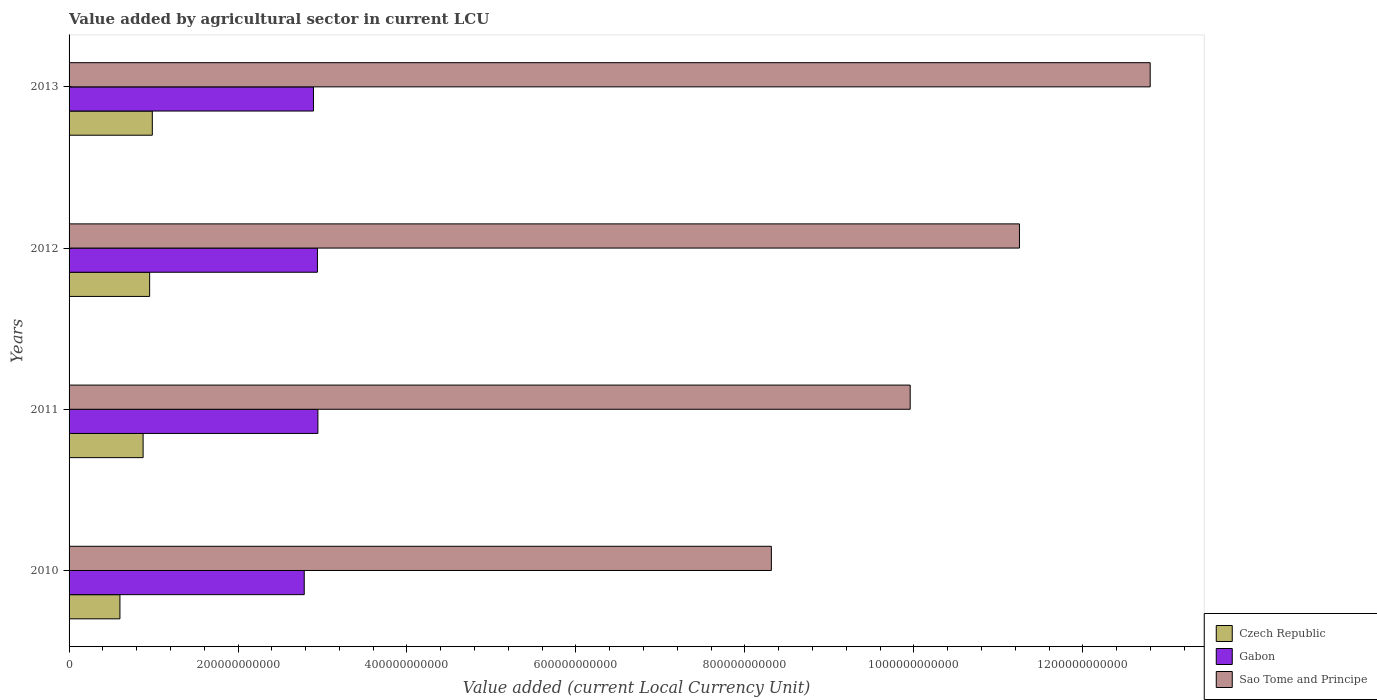How many groups of bars are there?
Offer a very short reply. 4. Are the number of bars per tick equal to the number of legend labels?
Make the answer very short. Yes. Are the number of bars on each tick of the Y-axis equal?
Your response must be concise. Yes. How many bars are there on the 4th tick from the top?
Ensure brevity in your answer.  3. What is the value added by agricultural sector in Czech Republic in 2013?
Offer a terse response. 9.85e+1. Across all years, what is the maximum value added by agricultural sector in Gabon?
Your response must be concise. 2.95e+11. Across all years, what is the minimum value added by agricultural sector in Sao Tome and Principe?
Offer a terse response. 8.31e+11. In which year was the value added by agricultural sector in Sao Tome and Principe minimum?
Give a very brief answer. 2010. What is the total value added by agricultural sector in Sao Tome and Principe in the graph?
Provide a short and direct response. 4.23e+12. What is the difference between the value added by agricultural sector in Czech Republic in 2010 and that in 2011?
Ensure brevity in your answer.  -2.74e+1. What is the difference between the value added by agricultural sector in Czech Republic in 2010 and the value added by agricultural sector in Gabon in 2013?
Make the answer very short. -2.29e+11. What is the average value added by agricultural sector in Sao Tome and Principe per year?
Ensure brevity in your answer.  1.06e+12. In the year 2011, what is the difference between the value added by agricultural sector in Sao Tome and Principe and value added by agricultural sector in Gabon?
Your response must be concise. 7.01e+11. What is the ratio of the value added by agricultural sector in Czech Republic in 2010 to that in 2011?
Make the answer very short. 0.69. Is the value added by agricultural sector in Sao Tome and Principe in 2011 less than that in 2012?
Make the answer very short. Yes. What is the difference between the highest and the second highest value added by agricultural sector in Sao Tome and Principe?
Give a very brief answer. 1.55e+11. What is the difference between the highest and the lowest value added by agricultural sector in Sao Tome and Principe?
Provide a succinct answer. 4.48e+11. What does the 2nd bar from the top in 2010 represents?
Provide a short and direct response. Gabon. What does the 3rd bar from the bottom in 2011 represents?
Offer a terse response. Sao Tome and Principe. Is it the case that in every year, the sum of the value added by agricultural sector in Sao Tome and Principe and value added by agricultural sector in Gabon is greater than the value added by agricultural sector in Czech Republic?
Your answer should be very brief. Yes. What is the difference between two consecutive major ticks on the X-axis?
Ensure brevity in your answer.  2.00e+11. Are the values on the major ticks of X-axis written in scientific E-notation?
Provide a succinct answer. No. Does the graph contain any zero values?
Make the answer very short. No. Does the graph contain grids?
Ensure brevity in your answer.  No. Where does the legend appear in the graph?
Keep it short and to the point. Bottom right. How are the legend labels stacked?
Offer a terse response. Vertical. What is the title of the graph?
Ensure brevity in your answer.  Value added by agricultural sector in current LCU. Does "Moldova" appear as one of the legend labels in the graph?
Your answer should be compact. No. What is the label or title of the X-axis?
Your answer should be compact. Value added (current Local Currency Unit). What is the Value added (current Local Currency Unit) in Czech Republic in 2010?
Ensure brevity in your answer.  6.02e+1. What is the Value added (current Local Currency Unit) of Gabon in 2010?
Provide a succinct answer. 2.78e+11. What is the Value added (current Local Currency Unit) of Sao Tome and Principe in 2010?
Keep it short and to the point. 8.31e+11. What is the Value added (current Local Currency Unit) in Czech Republic in 2011?
Your response must be concise. 8.76e+1. What is the Value added (current Local Currency Unit) in Gabon in 2011?
Your response must be concise. 2.95e+11. What is the Value added (current Local Currency Unit) in Sao Tome and Principe in 2011?
Your answer should be very brief. 9.96e+11. What is the Value added (current Local Currency Unit) of Czech Republic in 2012?
Provide a short and direct response. 9.54e+1. What is the Value added (current Local Currency Unit) of Gabon in 2012?
Keep it short and to the point. 2.94e+11. What is the Value added (current Local Currency Unit) in Sao Tome and Principe in 2012?
Your response must be concise. 1.13e+12. What is the Value added (current Local Currency Unit) in Czech Republic in 2013?
Your answer should be very brief. 9.85e+1. What is the Value added (current Local Currency Unit) in Gabon in 2013?
Your response must be concise. 2.89e+11. What is the Value added (current Local Currency Unit) of Sao Tome and Principe in 2013?
Keep it short and to the point. 1.28e+12. Across all years, what is the maximum Value added (current Local Currency Unit) in Czech Republic?
Your answer should be compact. 9.85e+1. Across all years, what is the maximum Value added (current Local Currency Unit) of Gabon?
Ensure brevity in your answer.  2.95e+11. Across all years, what is the maximum Value added (current Local Currency Unit) in Sao Tome and Principe?
Your response must be concise. 1.28e+12. Across all years, what is the minimum Value added (current Local Currency Unit) of Czech Republic?
Offer a terse response. 6.02e+1. Across all years, what is the minimum Value added (current Local Currency Unit) in Gabon?
Your response must be concise. 2.78e+11. Across all years, what is the minimum Value added (current Local Currency Unit) of Sao Tome and Principe?
Provide a succinct answer. 8.31e+11. What is the total Value added (current Local Currency Unit) of Czech Republic in the graph?
Keep it short and to the point. 3.42e+11. What is the total Value added (current Local Currency Unit) of Gabon in the graph?
Give a very brief answer. 1.16e+12. What is the total Value added (current Local Currency Unit) of Sao Tome and Principe in the graph?
Keep it short and to the point. 4.23e+12. What is the difference between the Value added (current Local Currency Unit) of Czech Republic in 2010 and that in 2011?
Keep it short and to the point. -2.74e+1. What is the difference between the Value added (current Local Currency Unit) in Gabon in 2010 and that in 2011?
Provide a short and direct response. -1.62e+1. What is the difference between the Value added (current Local Currency Unit) of Sao Tome and Principe in 2010 and that in 2011?
Your answer should be very brief. -1.64e+11. What is the difference between the Value added (current Local Currency Unit) in Czech Republic in 2010 and that in 2012?
Provide a succinct answer. -3.52e+1. What is the difference between the Value added (current Local Currency Unit) of Gabon in 2010 and that in 2012?
Ensure brevity in your answer.  -1.56e+1. What is the difference between the Value added (current Local Currency Unit) in Sao Tome and Principe in 2010 and that in 2012?
Your answer should be compact. -2.94e+11. What is the difference between the Value added (current Local Currency Unit) of Czech Republic in 2010 and that in 2013?
Offer a very short reply. -3.83e+1. What is the difference between the Value added (current Local Currency Unit) of Gabon in 2010 and that in 2013?
Make the answer very short. -1.09e+1. What is the difference between the Value added (current Local Currency Unit) of Sao Tome and Principe in 2010 and that in 2013?
Provide a short and direct response. -4.48e+11. What is the difference between the Value added (current Local Currency Unit) of Czech Republic in 2011 and that in 2012?
Provide a short and direct response. -7.74e+09. What is the difference between the Value added (current Local Currency Unit) of Gabon in 2011 and that in 2012?
Keep it short and to the point. 5.43e+08. What is the difference between the Value added (current Local Currency Unit) of Sao Tome and Principe in 2011 and that in 2012?
Ensure brevity in your answer.  -1.29e+11. What is the difference between the Value added (current Local Currency Unit) of Czech Republic in 2011 and that in 2013?
Give a very brief answer. -1.09e+1. What is the difference between the Value added (current Local Currency Unit) of Gabon in 2011 and that in 2013?
Offer a very short reply. 5.23e+09. What is the difference between the Value added (current Local Currency Unit) of Sao Tome and Principe in 2011 and that in 2013?
Your response must be concise. -2.84e+11. What is the difference between the Value added (current Local Currency Unit) in Czech Republic in 2012 and that in 2013?
Provide a short and direct response. -3.17e+09. What is the difference between the Value added (current Local Currency Unit) of Gabon in 2012 and that in 2013?
Ensure brevity in your answer.  4.69e+09. What is the difference between the Value added (current Local Currency Unit) in Sao Tome and Principe in 2012 and that in 2013?
Provide a short and direct response. -1.55e+11. What is the difference between the Value added (current Local Currency Unit) in Czech Republic in 2010 and the Value added (current Local Currency Unit) in Gabon in 2011?
Your answer should be very brief. -2.34e+11. What is the difference between the Value added (current Local Currency Unit) in Czech Republic in 2010 and the Value added (current Local Currency Unit) in Sao Tome and Principe in 2011?
Your answer should be very brief. -9.35e+11. What is the difference between the Value added (current Local Currency Unit) in Gabon in 2010 and the Value added (current Local Currency Unit) in Sao Tome and Principe in 2011?
Offer a very short reply. -7.17e+11. What is the difference between the Value added (current Local Currency Unit) in Czech Republic in 2010 and the Value added (current Local Currency Unit) in Gabon in 2012?
Give a very brief answer. -2.34e+11. What is the difference between the Value added (current Local Currency Unit) of Czech Republic in 2010 and the Value added (current Local Currency Unit) of Sao Tome and Principe in 2012?
Your answer should be compact. -1.06e+12. What is the difference between the Value added (current Local Currency Unit) of Gabon in 2010 and the Value added (current Local Currency Unit) of Sao Tome and Principe in 2012?
Keep it short and to the point. -8.47e+11. What is the difference between the Value added (current Local Currency Unit) of Czech Republic in 2010 and the Value added (current Local Currency Unit) of Gabon in 2013?
Your answer should be compact. -2.29e+11. What is the difference between the Value added (current Local Currency Unit) in Czech Republic in 2010 and the Value added (current Local Currency Unit) in Sao Tome and Principe in 2013?
Your answer should be very brief. -1.22e+12. What is the difference between the Value added (current Local Currency Unit) of Gabon in 2010 and the Value added (current Local Currency Unit) of Sao Tome and Principe in 2013?
Offer a terse response. -1.00e+12. What is the difference between the Value added (current Local Currency Unit) in Czech Republic in 2011 and the Value added (current Local Currency Unit) in Gabon in 2012?
Ensure brevity in your answer.  -2.06e+11. What is the difference between the Value added (current Local Currency Unit) of Czech Republic in 2011 and the Value added (current Local Currency Unit) of Sao Tome and Principe in 2012?
Your response must be concise. -1.04e+12. What is the difference between the Value added (current Local Currency Unit) of Gabon in 2011 and the Value added (current Local Currency Unit) of Sao Tome and Principe in 2012?
Give a very brief answer. -8.30e+11. What is the difference between the Value added (current Local Currency Unit) in Czech Republic in 2011 and the Value added (current Local Currency Unit) in Gabon in 2013?
Offer a very short reply. -2.02e+11. What is the difference between the Value added (current Local Currency Unit) in Czech Republic in 2011 and the Value added (current Local Currency Unit) in Sao Tome and Principe in 2013?
Provide a short and direct response. -1.19e+12. What is the difference between the Value added (current Local Currency Unit) of Gabon in 2011 and the Value added (current Local Currency Unit) of Sao Tome and Principe in 2013?
Provide a short and direct response. -9.85e+11. What is the difference between the Value added (current Local Currency Unit) in Czech Republic in 2012 and the Value added (current Local Currency Unit) in Gabon in 2013?
Give a very brief answer. -1.94e+11. What is the difference between the Value added (current Local Currency Unit) in Czech Republic in 2012 and the Value added (current Local Currency Unit) in Sao Tome and Principe in 2013?
Your response must be concise. -1.18e+12. What is the difference between the Value added (current Local Currency Unit) in Gabon in 2012 and the Value added (current Local Currency Unit) in Sao Tome and Principe in 2013?
Give a very brief answer. -9.86e+11. What is the average Value added (current Local Currency Unit) of Czech Republic per year?
Offer a very short reply. 8.54e+1. What is the average Value added (current Local Currency Unit) of Gabon per year?
Give a very brief answer. 2.89e+11. What is the average Value added (current Local Currency Unit) of Sao Tome and Principe per year?
Offer a terse response. 1.06e+12. In the year 2010, what is the difference between the Value added (current Local Currency Unit) of Czech Republic and Value added (current Local Currency Unit) of Gabon?
Keep it short and to the point. -2.18e+11. In the year 2010, what is the difference between the Value added (current Local Currency Unit) in Czech Republic and Value added (current Local Currency Unit) in Sao Tome and Principe?
Provide a succinct answer. -7.71e+11. In the year 2010, what is the difference between the Value added (current Local Currency Unit) of Gabon and Value added (current Local Currency Unit) of Sao Tome and Principe?
Provide a succinct answer. -5.53e+11. In the year 2011, what is the difference between the Value added (current Local Currency Unit) of Czech Republic and Value added (current Local Currency Unit) of Gabon?
Offer a terse response. -2.07e+11. In the year 2011, what is the difference between the Value added (current Local Currency Unit) in Czech Republic and Value added (current Local Currency Unit) in Sao Tome and Principe?
Offer a terse response. -9.08e+11. In the year 2011, what is the difference between the Value added (current Local Currency Unit) in Gabon and Value added (current Local Currency Unit) in Sao Tome and Principe?
Ensure brevity in your answer.  -7.01e+11. In the year 2012, what is the difference between the Value added (current Local Currency Unit) of Czech Republic and Value added (current Local Currency Unit) of Gabon?
Make the answer very short. -1.99e+11. In the year 2012, what is the difference between the Value added (current Local Currency Unit) of Czech Republic and Value added (current Local Currency Unit) of Sao Tome and Principe?
Make the answer very short. -1.03e+12. In the year 2012, what is the difference between the Value added (current Local Currency Unit) of Gabon and Value added (current Local Currency Unit) of Sao Tome and Principe?
Make the answer very short. -8.31e+11. In the year 2013, what is the difference between the Value added (current Local Currency Unit) in Czech Republic and Value added (current Local Currency Unit) in Gabon?
Make the answer very short. -1.91e+11. In the year 2013, what is the difference between the Value added (current Local Currency Unit) of Czech Republic and Value added (current Local Currency Unit) of Sao Tome and Principe?
Make the answer very short. -1.18e+12. In the year 2013, what is the difference between the Value added (current Local Currency Unit) in Gabon and Value added (current Local Currency Unit) in Sao Tome and Principe?
Offer a very short reply. -9.90e+11. What is the ratio of the Value added (current Local Currency Unit) in Czech Republic in 2010 to that in 2011?
Provide a succinct answer. 0.69. What is the ratio of the Value added (current Local Currency Unit) of Gabon in 2010 to that in 2011?
Your answer should be compact. 0.95. What is the ratio of the Value added (current Local Currency Unit) of Sao Tome and Principe in 2010 to that in 2011?
Your answer should be very brief. 0.83. What is the ratio of the Value added (current Local Currency Unit) in Czech Republic in 2010 to that in 2012?
Give a very brief answer. 0.63. What is the ratio of the Value added (current Local Currency Unit) in Gabon in 2010 to that in 2012?
Your response must be concise. 0.95. What is the ratio of the Value added (current Local Currency Unit) of Sao Tome and Principe in 2010 to that in 2012?
Your response must be concise. 0.74. What is the ratio of the Value added (current Local Currency Unit) of Czech Republic in 2010 to that in 2013?
Keep it short and to the point. 0.61. What is the ratio of the Value added (current Local Currency Unit) of Gabon in 2010 to that in 2013?
Ensure brevity in your answer.  0.96. What is the ratio of the Value added (current Local Currency Unit) of Sao Tome and Principe in 2010 to that in 2013?
Your answer should be very brief. 0.65. What is the ratio of the Value added (current Local Currency Unit) in Czech Republic in 2011 to that in 2012?
Offer a terse response. 0.92. What is the ratio of the Value added (current Local Currency Unit) of Gabon in 2011 to that in 2012?
Keep it short and to the point. 1. What is the ratio of the Value added (current Local Currency Unit) of Sao Tome and Principe in 2011 to that in 2012?
Keep it short and to the point. 0.89. What is the ratio of the Value added (current Local Currency Unit) in Czech Republic in 2011 to that in 2013?
Keep it short and to the point. 0.89. What is the ratio of the Value added (current Local Currency Unit) in Gabon in 2011 to that in 2013?
Ensure brevity in your answer.  1.02. What is the ratio of the Value added (current Local Currency Unit) of Sao Tome and Principe in 2011 to that in 2013?
Your response must be concise. 0.78. What is the ratio of the Value added (current Local Currency Unit) of Czech Republic in 2012 to that in 2013?
Offer a terse response. 0.97. What is the ratio of the Value added (current Local Currency Unit) of Gabon in 2012 to that in 2013?
Your response must be concise. 1.02. What is the ratio of the Value added (current Local Currency Unit) of Sao Tome and Principe in 2012 to that in 2013?
Ensure brevity in your answer.  0.88. What is the difference between the highest and the second highest Value added (current Local Currency Unit) in Czech Republic?
Your response must be concise. 3.17e+09. What is the difference between the highest and the second highest Value added (current Local Currency Unit) in Gabon?
Offer a terse response. 5.43e+08. What is the difference between the highest and the second highest Value added (current Local Currency Unit) of Sao Tome and Principe?
Make the answer very short. 1.55e+11. What is the difference between the highest and the lowest Value added (current Local Currency Unit) in Czech Republic?
Your response must be concise. 3.83e+1. What is the difference between the highest and the lowest Value added (current Local Currency Unit) in Gabon?
Keep it short and to the point. 1.62e+1. What is the difference between the highest and the lowest Value added (current Local Currency Unit) of Sao Tome and Principe?
Your response must be concise. 4.48e+11. 